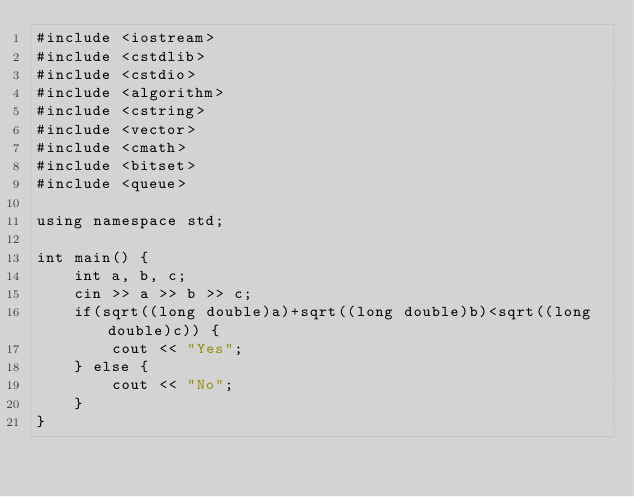<code> <loc_0><loc_0><loc_500><loc_500><_C++_>#include <iostream>
#include <cstdlib>
#include <cstdio>
#include <algorithm>
#include <cstring>
#include <vector>
#include <cmath>
#include <bitset>
#include <queue>

using namespace std;

int main() {
    int a, b, c;
    cin >> a >> b >> c;
    if(sqrt((long double)a)+sqrt((long double)b)<sqrt((long double)c)) {
        cout << "Yes";
    } else {
        cout << "No";
    }
}</code> 